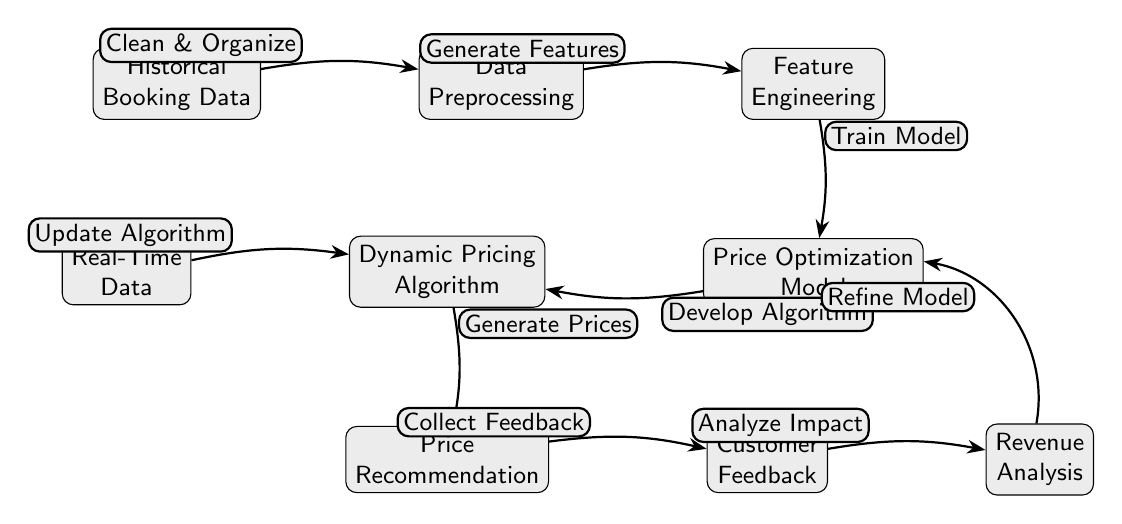What is the first node in the diagram? The first node is "Historical Booking Data," as it is positioned farthest to the left and serves as the initial input.
Answer: Historical Booking Data How many nodes are present in the diagram? By counting all individual elements in the diagram, including all processes and outputs, there are a total of eight nodes.
Answer: Eight What is the output of the "Price Optimization Model"? The output of the "Price Optimization Model" is directed towards the "Dynamic Pricing Algorithm," which is the next node in the flow.
Answer: Dynamic Pricing Algorithm What is the function of the "Real-Time Data"? The "Real-Time Data" is used to update the "Dynamic Pricing Algorithm," indicating it plays a critical role in keeping the pricing strategy current.
Answer: Update Algorithm What process comes after "Feature Engineering"? Directly following "Feature Engineering," the process is the "Price Optimization Model," reflecting the sequence in the diagram.
Answer: Price Optimization Model How does "Customer Feedback" contribute to the diagram? "Customer Feedback" analyzes the impact of the price recommendations, which circles back to refine the model, a crucial feedback loop in optimizing pricing.
Answer: Analyze Impact What is the final node in the diagram? The final node in the diagram is "Revenue Analysis," which is the last step indicating it assesses the financial outcomes of the prior processes.
Answer: Revenue Analysis How is feedback used in the workflow? Feedback is collected after generating price recommendations, which then is analyzed to evaluate its impact on revenue, contributing to model refinement.
Answer: Refine Model What relationship does "Price Recommendation" have with "Customer Feedback"? "Price Recommendation" has a direct relationship with "Customer Feedback," as the feedback is collected based on the recommendations made.
Answer: Collect Feedback 